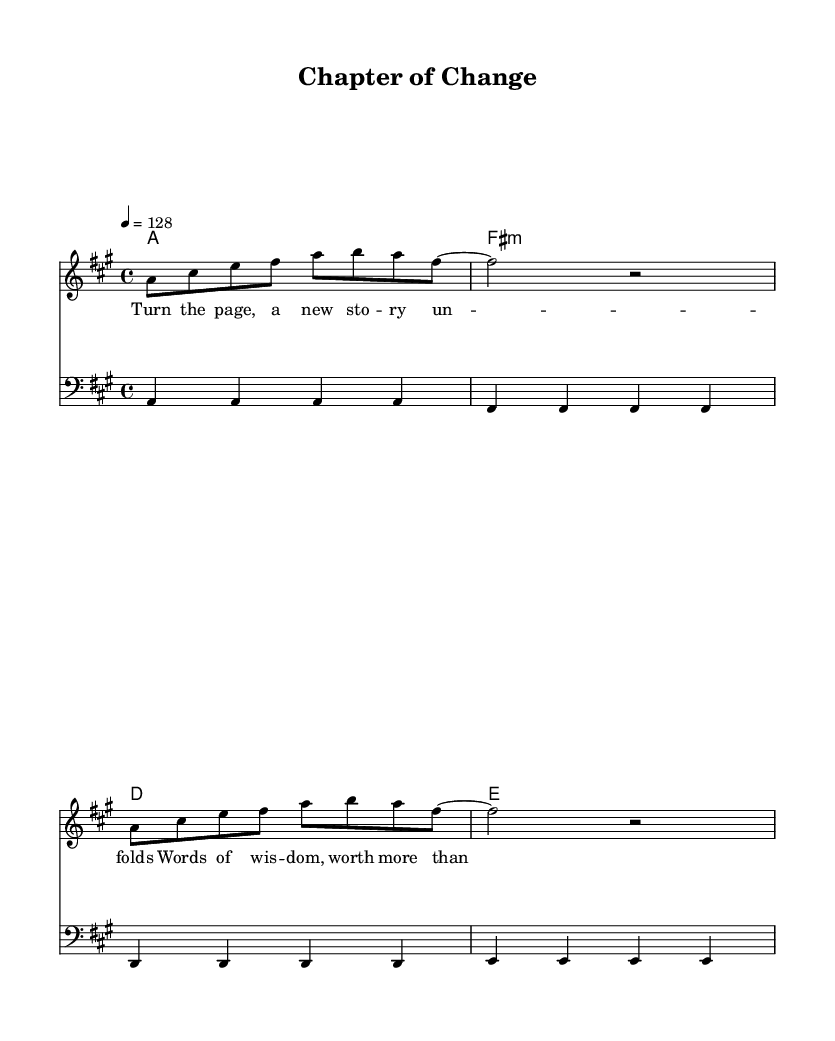What is the key signature of this music? The key signature is indicated by the presence of the sharp notes in the scale and is identified in the global variable. Here, there is one sharp (C#), which pertains to the key of A major.
Answer: A major What is the time signature of this music? The time signature is shown at the beginning of the score in the global variable. The notation "4/4" indicates a common time signature, where there are four beats per measure.
Answer: 4/4 What is the tempo marking indicated in this music? The tempo is specified in the global variable where it states "4 = 128," meaning the quarter note gets a beat of 128 beats per minute.
Answer: 128 BPM What is the name of the main melody section? The main melody is labeled as "melody" in the staff description within the score. It is distinctively separated from other elements like harmonies and bass.
Answer: melody How many different chords are used in the harmony section? The list of chords appears in the chord mode section. There are four separate chords: A, F♯ minor, D, and E, thus constituting four different chords in total.
Answer: 4 What is the type of the last chord in the harmony section? The last chord is labeled as E in the harmony section. Other chord types can be inferred from their formulas, but E is the identifying name in the score.
Answer: E What theme does the lyric of the song suggest? The lyrics reference personal growth and wisdom, suggesting a theme of change and transformation, as reflected by phrases like "Turn the page" and "new story unfolds."
Answer: personal growth 